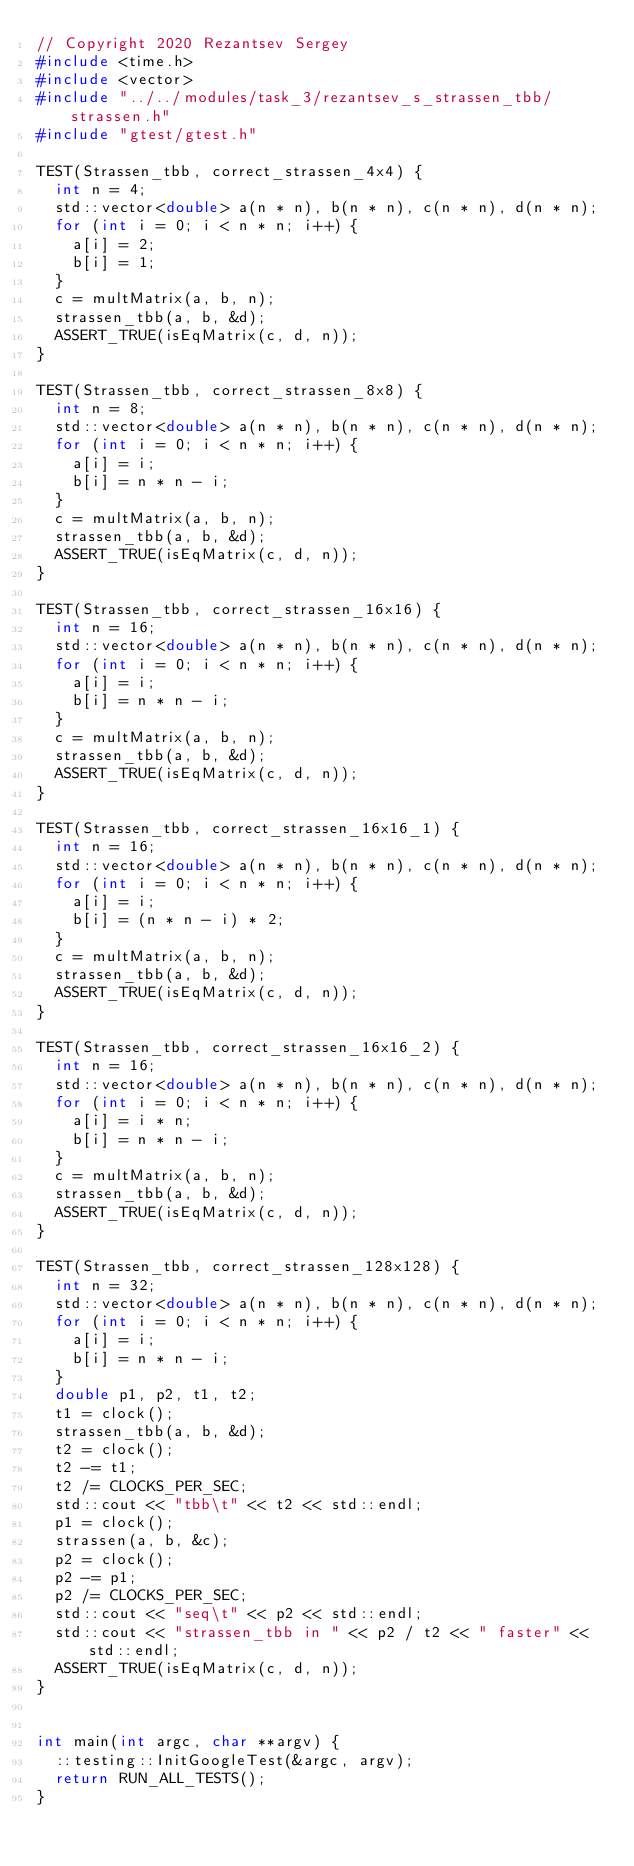Convert code to text. <code><loc_0><loc_0><loc_500><loc_500><_C++_>// Copyright 2020 Rezantsev Sergey
#include <time.h>
#include <vector>
#include "../../modules/task_3/rezantsev_s_strassen_tbb/strassen.h"
#include "gtest/gtest.h"

TEST(Strassen_tbb, correct_strassen_4x4) {
  int n = 4;
  std::vector<double> a(n * n), b(n * n), c(n * n), d(n * n);
  for (int i = 0; i < n * n; i++) {
    a[i] = 2;
    b[i] = 1;
  }
  c = multMatrix(a, b, n);
  strassen_tbb(a, b, &d);
  ASSERT_TRUE(isEqMatrix(c, d, n));
}

TEST(Strassen_tbb, correct_strassen_8x8) {
  int n = 8;
  std::vector<double> a(n * n), b(n * n), c(n * n), d(n * n);
  for (int i = 0; i < n * n; i++) {
    a[i] = i;
    b[i] = n * n - i;
  }
  c = multMatrix(a, b, n);
  strassen_tbb(a, b, &d);
  ASSERT_TRUE(isEqMatrix(c, d, n));
}

TEST(Strassen_tbb, correct_strassen_16x16) {
  int n = 16;
  std::vector<double> a(n * n), b(n * n), c(n * n), d(n * n);
  for (int i = 0; i < n * n; i++) {
    a[i] = i;
    b[i] = n * n - i;
  }
  c = multMatrix(a, b, n);
  strassen_tbb(a, b, &d);
  ASSERT_TRUE(isEqMatrix(c, d, n));
}

TEST(Strassen_tbb, correct_strassen_16x16_1) {
  int n = 16;
  std::vector<double> a(n * n), b(n * n), c(n * n), d(n * n);
  for (int i = 0; i < n * n; i++) {
    a[i] = i;
    b[i] = (n * n - i) * 2;
  }
  c = multMatrix(a, b, n);
  strassen_tbb(a, b, &d);
  ASSERT_TRUE(isEqMatrix(c, d, n));
}

TEST(Strassen_tbb, correct_strassen_16x16_2) {
  int n = 16;
  std::vector<double> a(n * n), b(n * n), c(n * n), d(n * n);
  for (int i = 0; i < n * n; i++) {
    a[i] = i * n;
    b[i] = n * n - i;
  }
  c = multMatrix(a, b, n);
  strassen_tbb(a, b, &d);
  ASSERT_TRUE(isEqMatrix(c, d, n));
}

TEST(Strassen_tbb, correct_strassen_128x128) {
  int n = 32;
  std::vector<double> a(n * n), b(n * n), c(n * n), d(n * n);
  for (int i = 0; i < n * n; i++) {
    a[i] = i;
    b[i] = n * n - i;
  }
  double p1, p2, t1, t2;
  t1 = clock();
  strassen_tbb(a, b, &d);
  t2 = clock();
  t2 -= t1;
  t2 /= CLOCKS_PER_SEC;
  std::cout << "tbb\t" << t2 << std::endl;
  p1 = clock();
  strassen(a, b, &c);
  p2 = clock();
  p2 -= p1;
  p2 /= CLOCKS_PER_SEC;
  std::cout << "seq\t" << p2 << std::endl;
  std::cout << "strassen_tbb in " << p2 / t2 << " faster" << std::endl;
  ASSERT_TRUE(isEqMatrix(c, d, n));
}


int main(int argc, char **argv) {
  ::testing::InitGoogleTest(&argc, argv);
  return RUN_ALL_TESTS();
}
</code> 